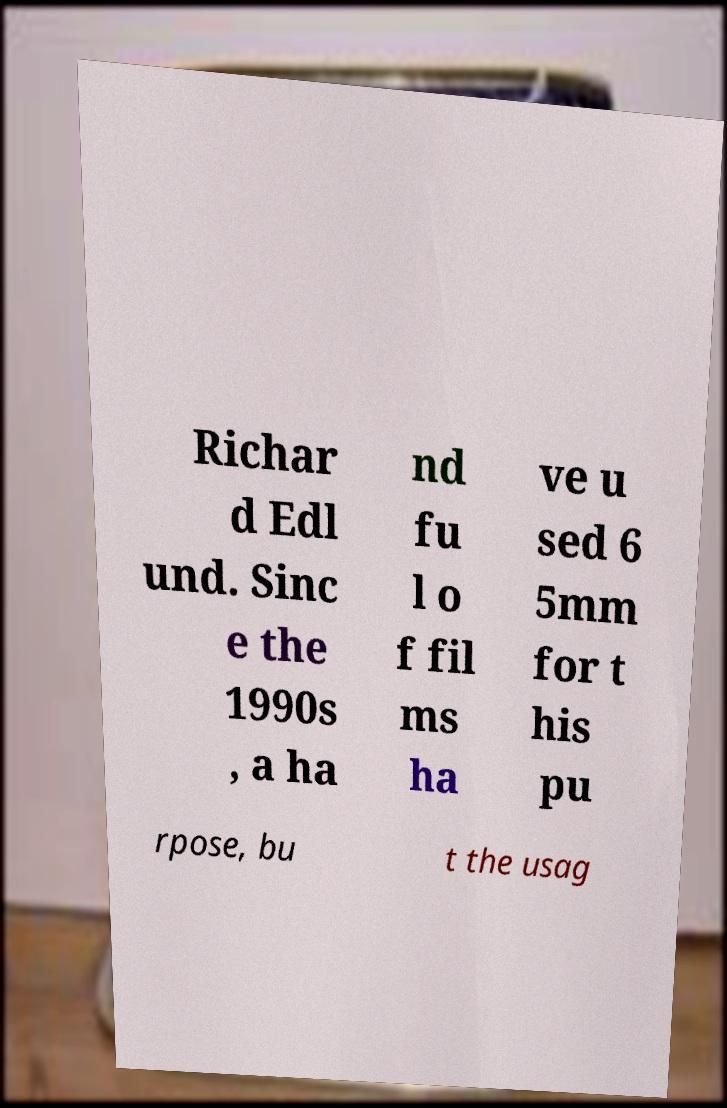Could you assist in decoding the text presented in this image and type it out clearly? Richar d Edl und. Sinc e the 1990s , a ha nd fu l o f fil ms ha ve u sed 6 5mm for t his pu rpose, bu t the usag 